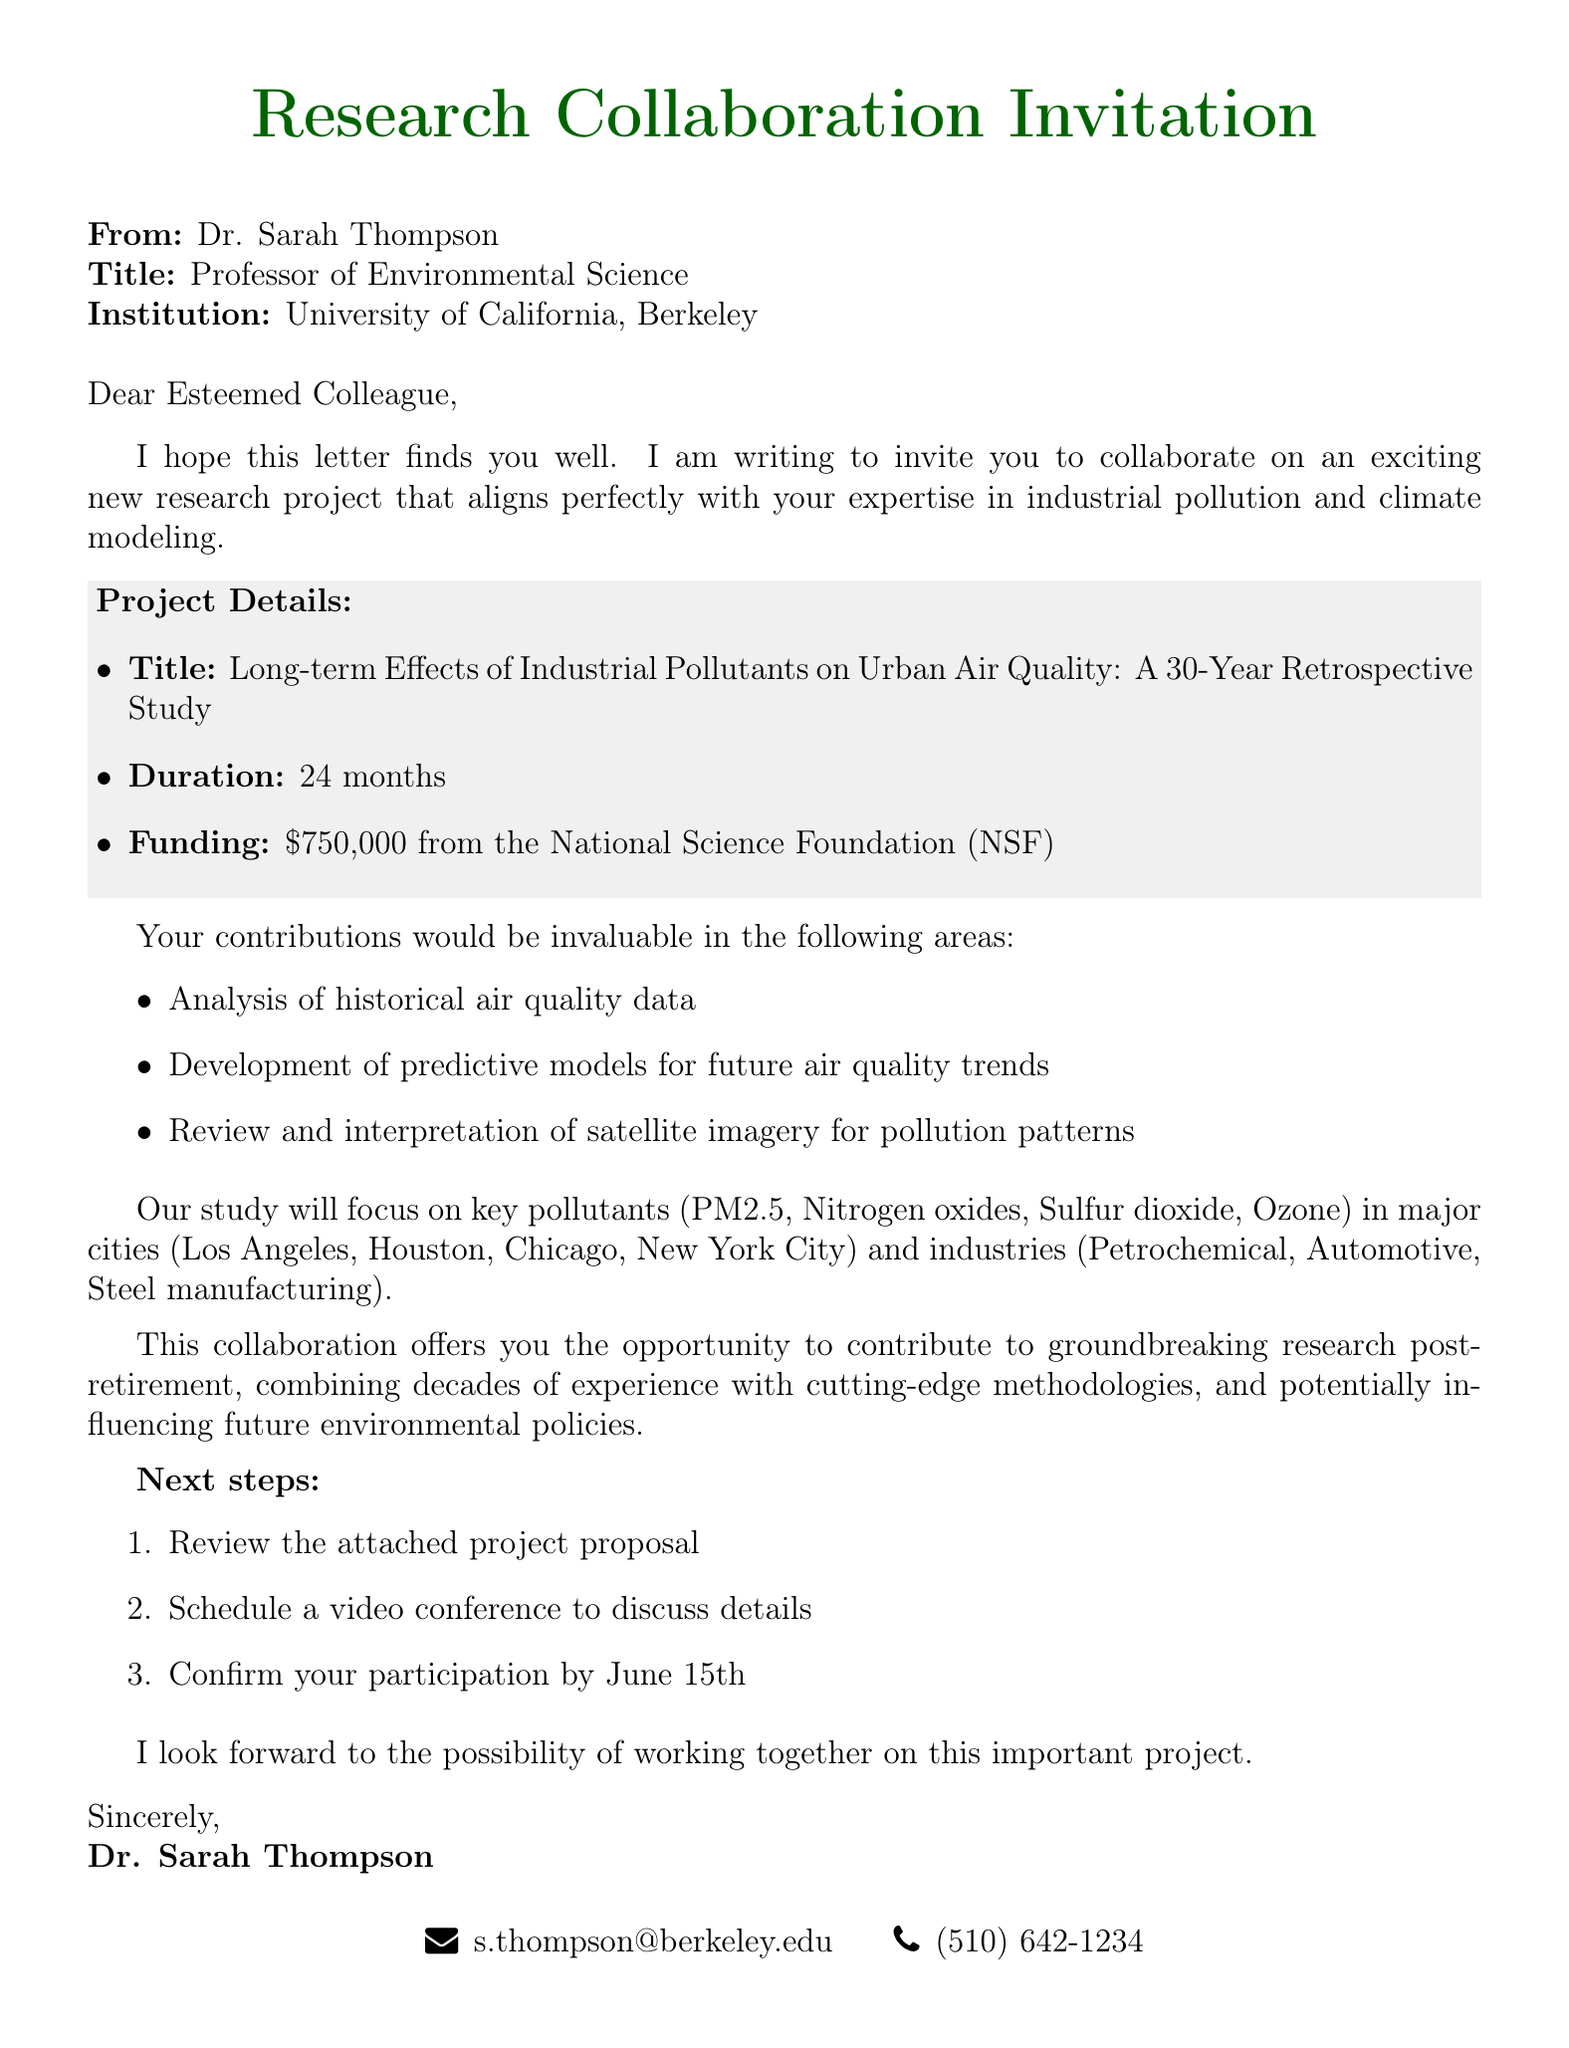What is the title of the research project? The project title is specifically provided in the document under project details.
Answer: Long-term Effects of Industrial Pollutants on Urban Air Quality: A 30-Year Retrospective Study Who is the sender of the letter? The sender's information, including name and title, is listed at the beginning of the document.
Answer: Dr. Sarah Thompson What is the duration of the research project? The duration is mentioned in the project details section of the document.
Answer: 24 months What are the pollutants that the study will focus on? The specific pollutants to be studied are listed in the document's study focus section.
Answer: PM2.5, Nitrogen oxides, Sulfur dioxide, Ozone What is the funding amount for the project? The funding amount is indicated in the project details section of the letter.
Answer: $750,000 What is the deadline to confirm participation? The document specifies the date by which participation confirmation is required.
Answer: June 15th What are the three specific contributions requested from the recipient? The specific contributions are listed, which require analytic efforts and expertise in pollution and climate modeling.
Answer: Analysis of historical air quality data, Development of predictive models for future air quality trends, Review and interpretation of satellite imagery for pollution patterns What is one potential outcome of the research collaboration? Potential outcomes are highlighted in the document as benefits of the collaboration.
Answer: Improved urban planning strategies 